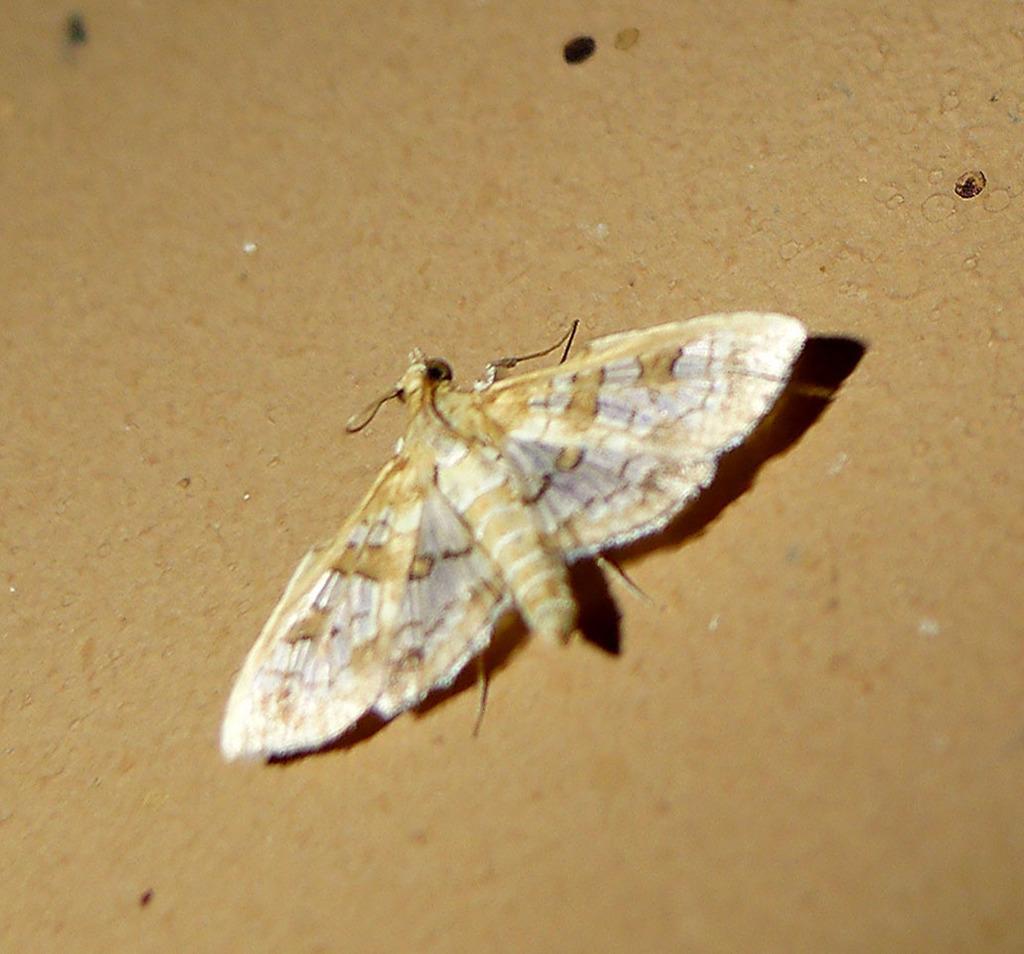Could you give a brief overview of what you see in this image? In the middle of the image we can see an insect on a brown color surface. 